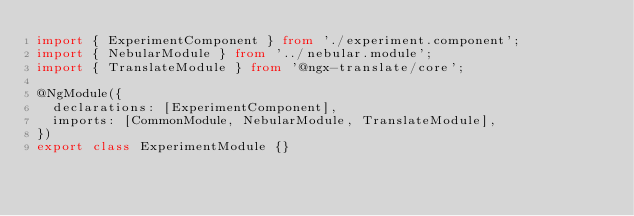Convert code to text. <code><loc_0><loc_0><loc_500><loc_500><_TypeScript_>import { ExperimentComponent } from './experiment.component';
import { NebularModule } from '../nebular.module';
import { TranslateModule } from '@ngx-translate/core';

@NgModule({
  declarations: [ExperimentComponent],
  imports: [CommonModule, NebularModule, TranslateModule],
})
export class ExperimentModule {}
</code> 